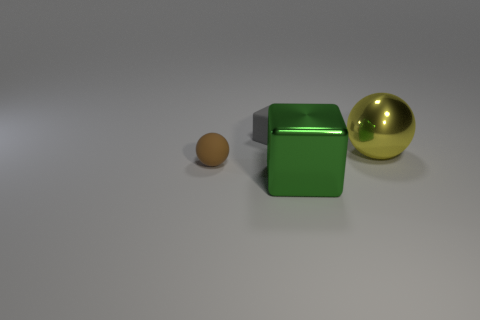Is the size of the green shiny block the same as the object that is behind the big metal ball?
Provide a succinct answer. No. How many things are spheres that are on the left side of the small gray object or blocks that are in front of the tiny brown matte sphere?
Make the answer very short. 2. The green object that is the same size as the metallic sphere is what shape?
Give a very brief answer. Cube. What shape is the rubber object in front of the large object behind the small brown rubber thing that is left of the green metal thing?
Provide a succinct answer. Sphere. Are there an equal number of tiny blocks behind the green block and large cyan spheres?
Make the answer very short. No. Does the metal block have the same size as the shiny sphere?
Offer a terse response. Yes. What number of metal things are large blue things or tiny cubes?
Provide a short and direct response. 0. There is a gray object that is the same size as the brown rubber sphere; what is its material?
Offer a very short reply. Rubber. What number of other things are there of the same material as the large green object
Your answer should be very brief. 1. Are there fewer large things left of the big yellow sphere than small yellow shiny things?
Keep it short and to the point. No. 